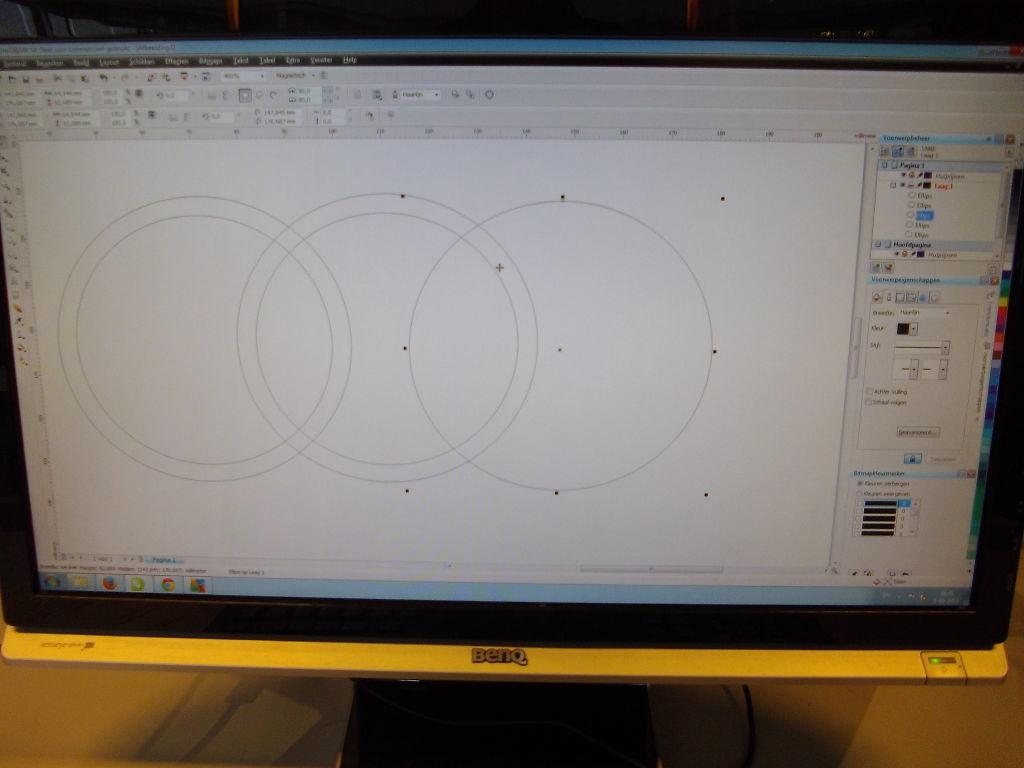<image>
Provide a brief description of the given image. a benq computer screen that has a diagram on the screen 